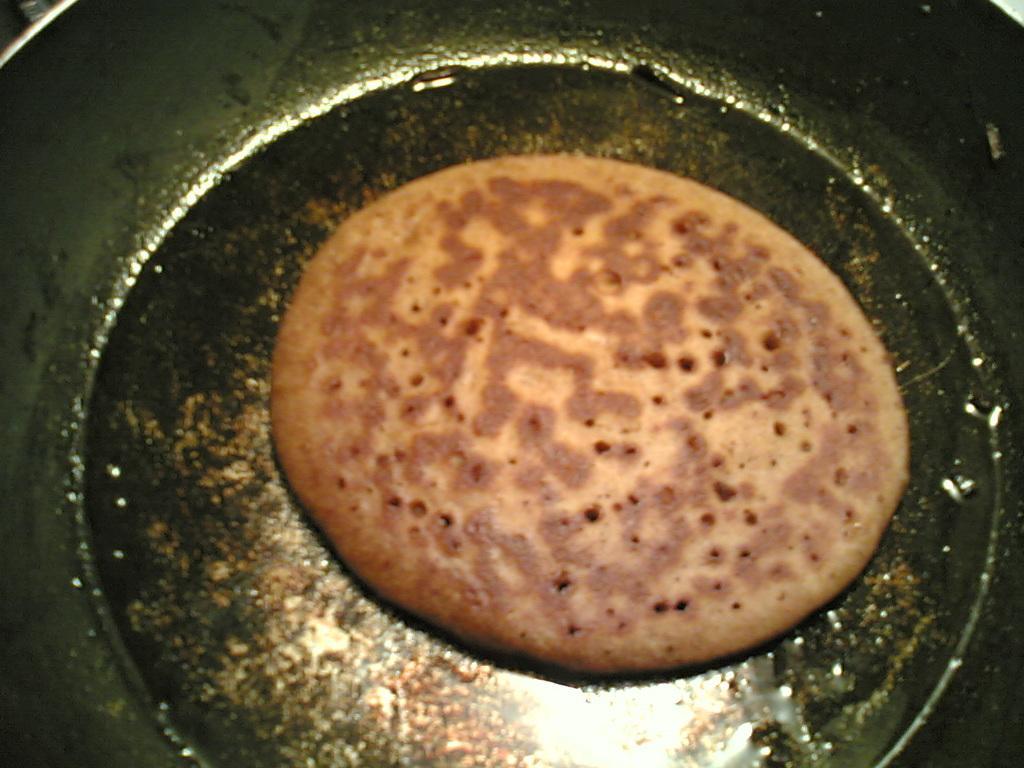Can you describe this image briefly? In this picture I can see some food in the pan. 